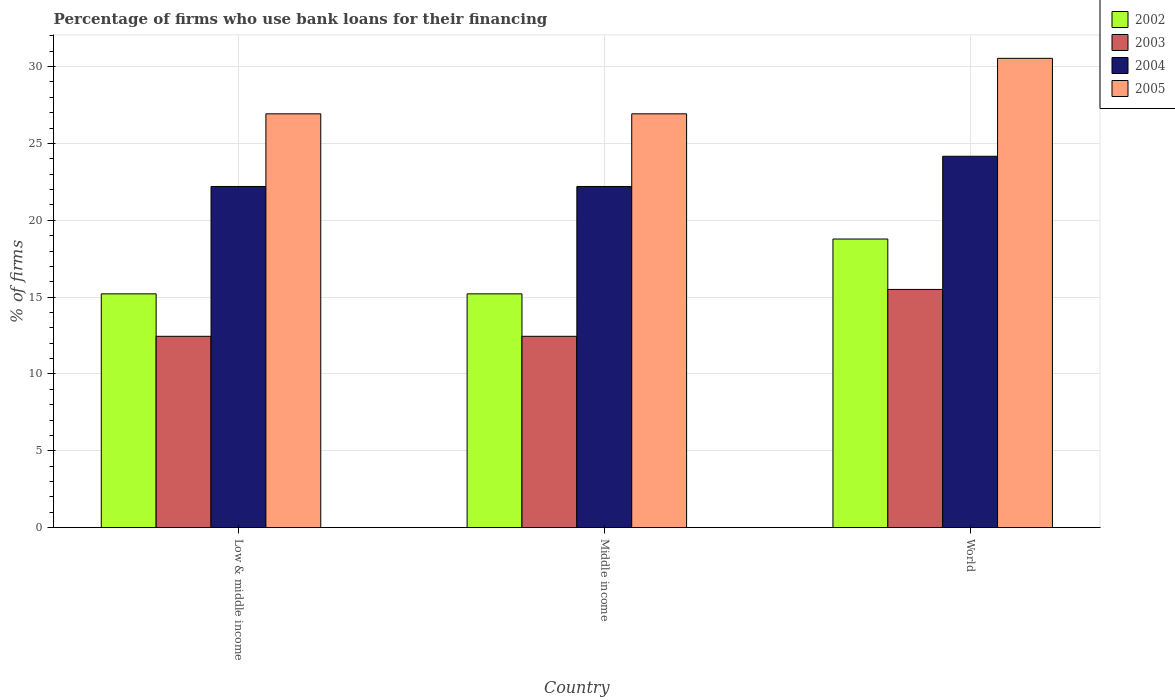How many groups of bars are there?
Keep it short and to the point. 3. What is the label of the 3rd group of bars from the left?
Your response must be concise. World. What is the percentage of firms who use bank loans for their financing in 2005 in Middle income?
Ensure brevity in your answer.  26.93. Across all countries, what is the maximum percentage of firms who use bank loans for their financing in 2003?
Provide a succinct answer. 15.5. Across all countries, what is the minimum percentage of firms who use bank loans for their financing in 2005?
Offer a terse response. 26.93. What is the total percentage of firms who use bank loans for their financing in 2002 in the graph?
Give a very brief answer. 49.21. What is the difference between the percentage of firms who use bank loans for their financing in 2004 in Middle income and the percentage of firms who use bank loans for their financing in 2003 in World?
Your answer should be very brief. 6.7. What is the average percentage of firms who use bank loans for their financing in 2004 per country?
Provide a succinct answer. 22.86. What is the difference between the percentage of firms who use bank loans for their financing of/in 2005 and percentage of firms who use bank loans for their financing of/in 2002 in World?
Provide a succinct answer. 11.76. What is the ratio of the percentage of firms who use bank loans for their financing in 2003 in Middle income to that in World?
Offer a terse response. 0.8. Is the percentage of firms who use bank loans for their financing in 2005 in Middle income less than that in World?
Your answer should be very brief. Yes. Is the difference between the percentage of firms who use bank loans for their financing in 2005 in Low & middle income and World greater than the difference between the percentage of firms who use bank loans for their financing in 2002 in Low & middle income and World?
Your response must be concise. No. What is the difference between the highest and the second highest percentage of firms who use bank loans for their financing in 2003?
Make the answer very short. -3.05. What is the difference between the highest and the lowest percentage of firms who use bank loans for their financing in 2002?
Make the answer very short. 3.57. Is the sum of the percentage of firms who use bank loans for their financing in 2003 in Low & middle income and Middle income greater than the maximum percentage of firms who use bank loans for their financing in 2005 across all countries?
Ensure brevity in your answer.  No. What does the 1st bar from the right in Middle income represents?
Offer a terse response. 2005. Is it the case that in every country, the sum of the percentage of firms who use bank loans for their financing in 2004 and percentage of firms who use bank loans for their financing in 2005 is greater than the percentage of firms who use bank loans for their financing in 2003?
Your response must be concise. Yes. How many bars are there?
Ensure brevity in your answer.  12. Are the values on the major ticks of Y-axis written in scientific E-notation?
Your response must be concise. No. Does the graph contain any zero values?
Ensure brevity in your answer.  No. Does the graph contain grids?
Offer a terse response. Yes. How many legend labels are there?
Ensure brevity in your answer.  4. How are the legend labels stacked?
Give a very brief answer. Vertical. What is the title of the graph?
Your answer should be compact. Percentage of firms who use bank loans for their financing. Does "1990" appear as one of the legend labels in the graph?
Offer a very short reply. No. What is the label or title of the X-axis?
Make the answer very short. Country. What is the label or title of the Y-axis?
Provide a succinct answer. % of firms. What is the % of firms in 2002 in Low & middle income?
Offer a very short reply. 15.21. What is the % of firms of 2003 in Low & middle income?
Keep it short and to the point. 12.45. What is the % of firms in 2005 in Low & middle income?
Give a very brief answer. 26.93. What is the % of firms in 2002 in Middle income?
Offer a very short reply. 15.21. What is the % of firms in 2003 in Middle income?
Keep it short and to the point. 12.45. What is the % of firms of 2005 in Middle income?
Provide a succinct answer. 26.93. What is the % of firms in 2002 in World?
Make the answer very short. 18.78. What is the % of firms in 2003 in World?
Keep it short and to the point. 15.5. What is the % of firms of 2004 in World?
Your answer should be compact. 24.17. What is the % of firms in 2005 in World?
Make the answer very short. 30.54. Across all countries, what is the maximum % of firms of 2002?
Provide a short and direct response. 18.78. Across all countries, what is the maximum % of firms of 2003?
Your answer should be very brief. 15.5. Across all countries, what is the maximum % of firms in 2004?
Your response must be concise. 24.17. Across all countries, what is the maximum % of firms of 2005?
Make the answer very short. 30.54. Across all countries, what is the minimum % of firms of 2002?
Ensure brevity in your answer.  15.21. Across all countries, what is the minimum % of firms of 2003?
Ensure brevity in your answer.  12.45. Across all countries, what is the minimum % of firms of 2005?
Ensure brevity in your answer.  26.93. What is the total % of firms of 2002 in the graph?
Your response must be concise. 49.21. What is the total % of firms of 2003 in the graph?
Your answer should be compact. 40.4. What is the total % of firms of 2004 in the graph?
Your answer should be compact. 68.57. What is the total % of firms of 2005 in the graph?
Give a very brief answer. 84.39. What is the difference between the % of firms in 2003 in Low & middle income and that in Middle income?
Your response must be concise. 0. What is the difference between the % of firms of 2004 in Low & middle income and that in Middle income?
Keep it short and to the point. 0. What is the difference between the % of firms in 2002 in Low & middle income and that in World?
Ensure brevity in your answer.  -3.57. What is the difference between the % of firms of 2003 in Low & middle income and that in World?
Keep it short and to the point. -3.05. What is the difference between the % of firms of 2004 in Low & middle income and that in World?
Ensure brevity in your answer.  -1.97. What is the difference between the % of firms in 2005 in Low & middle income and that in World?
Offer a terse response. -3.61. What is the difference between the % of firms of 2002 in Middle income and that in World?
Offer a terse response. -3.57. What is the difference between the % of firms in 2003 in Middle income and that in World?
Make the answer very short. -3.05. What is the difference between the % of firms of 2004 in Middle income and that in World?
Your answer should be very brief. -1.97. What is the difference between the % of firms in 2005 in Middle income and that in World?
Offer a terse response. -3.61. What is the difference between the % of firms in 2002 in Low & middle income and the % of firms in 2003 in Middle income?
Your answer should be very brief. 2.76. What is the difference between the % of firms in 2002 in Low & middle income and the % of firms in 2004 in Middle income?
Provide a short and direct response. -6.99. What is the difference between the % of firms in 2002 in Low & middle income and the % of firms in 2005 in Middle income?
Your answer should be compact. -11.72. What is the difference between the % of firms of 2003 in Low & middle income and the % of firms of 2004 in Middle income?
Keep it short and to the point. -9.75. What is the difference between the % of firms in 2003 in Low & middle income and the % of firms in 2005 in Middle income?
Ensure brevity in your answer.  -14.48. What is the difference between the % of firms in 2004 in Low & middle income and the % of firms in 2005 in Middle income?
Keep it short and to the point. -4.73. What is the difference between the % of firms in 2002 in Low & middle income and the % of firms in 2003 in World?
Provide a short and direct response. -0.29. What is the difference between the % of firms in 2002 in Low & middle income and the % of firms in 2004 in World?
Make the answer very short. -8.95. What is the difference between the % of firms of 2002 in Low & middle income and the % of firms of 2005 in World?
Make the answer very short. -15.33. What is the difference between the % of firms of 2003 in Low & middle income and the % of firms of 2004 in World?
Your response must be concise. -11.72. What is the difference between the % of firms of 2003 in Low & middle income and the % of firms of 2005 in World?
Keep it short and to the point. -18.09. What is the difference between the % of firms of 2004 in Low & middle income and the % of firms of 2005 in World?
Ensure brevity in your answer.  -8.34. What is the difference between the % of firms in 2002 in Middle income and the % of firms in 2003 in World?
Offer a terse response. -0.29. What is the difference between the % of firms of 2002 in Middle income and the % of firms of 2004 in World?
Ensure brevity in your answer.  -8.95. What is the difference between the % of firms in 2002 in Middle income and the % of firms in 2005 in World?
Offer a very short reply. -15.33. What is the difference between the % of firms of 2003 in Middle income and the % of firms of 2004 in World?
Make the answer very short. -11.72. What is the difference between the % of firms in 2003 in Middle income and the % of firms in 2005 in World?
Give a very brief answer. -18.09. What is the difference between the % of firms in 2004 in Middle income and the % of firms in 2005 in World?
Provide a short and direct response. -8.34. What is the average % of firms of 2002 per country?
Your answer should be very brief. 16.4. What is the average % of firms in 2003 per country?
Keep it short and to the point. 13.47. What is the average % of firms of 2004 per country?
Your response must be concise. 22.86. What is the average % of firms of 2005 per country?
Offer a very short reply. 28.13. What is the difference between the % of firms in 2002 and % of firms in 2003 in Low & middle income?
Offer a very short reply. 2.76. What is the difference between the % of firms in 2002 and % of firms in 2004 in Low & middle income?
Give a very brief answer. -6.99. What is the difference between the % of firms in 2002 and % of firms in 2005 in Low & middle income?
Keep it short and to the point. -11.72. What is the difference between the % of firms in 2003 and % of firms in 2004 in Low & middle income?
Ensure brevity in your answer.  -9.75. What is the difference between the % of firms of 2003 and % of firms of 2005 in Low & middle income?
Provide a succinct answer. -14.48. What is the difference between the % of firms in 2004 and % of firms in 2005 in Low & middle income?
Offer a terse response. -4.73. What is the difference between the % of firms of 2002 and % of firms of 2003 in Middle income?
Offer a very short reply. 2.76. What is the difference between the % of firms in 2002 and % of firms in 2004 in Middle income?
Your answer should be very brief. -6.99. What is the difference between the % of firms of 2002 and % of firms of 2005 in Middle income?
Your response must be concise. -11.72. What is the difference between the % of firms in 2003 and % of firms in 2004 in Middle income?
Make the answer very short. -9.75. What is the difference between the % of firms of 2003 and % of firms of 2005 in Middle income?
Provide a succinct answer. -14.48. What is the difference between the % of firms of 2004 and % of firms of 2005 in Middle income?
Offer a terse response. -4.73. What is the difference between the % of firms in 2002 and % of firms in 2003 in World?
Your response must be concise. 3.28. What is the difference between the % of firms of 2002 and % of firms of 2004 in World?
Ensure brevity in your answer.  -5.39. What is the difference between the % of firms in 2002 and % of firms in 2005 in World?
Keep it short and to the point. -11.76. What is the difference between the % of firms in 2003 and % of firms in 2004 in World?
Give a very brief answer. -8.67. What is the difference between the % of firms in 2003 and % of firms in 2005 in World?
Your response must be concise. -15.04. What is the difference between the % of firms in 2004 and % of firms in 2005 in World?
Give a very brief answer. -6.37. What is the ratio of the % of firms of 2002 in Low & middle income to that in Middle income?
Your answer should be very brief. 1. What is the ratio of the % of firms in 2003 in Low & middle income to that in Middle income?
Give a very brief answer. 1. What is the ratio of the % of firms of 2002 in Low & middle income to that in World?
Offer a terse response. 0.81. What is the ratio of the % of firms of 2003 in Low & middle income to that in World?
Offer a very short reply. 0.8. What is the ratio of the % of firms in 2004 in Low & middle income to that in World?
Your answer should be compact. 0.92. What is the ratio of the % of firms of 2005 in Low & middle income to that in World?
Provide a short and direct response. 0.88. What is the ratio of the % of firms in 2002 in Middle income to that in World?
Ensure brevity in your answer.  0.81. What is the ratio of the % of firms of 2003 in Middle income to that in World?
Ensure brevity in your answer.  0.8. What is the ratio of the % of firms of 2004 in Middle income to that in World?
Provide a short and direct response. 0.92. What is the ratio of the % of firms in 2005 in Middle income to that in World?
Your answer should be compact. 0.88. What is the difference between the highest and the second highest % of firms of 2002?
Offer a very short reply. 3.57. What is the difference between the highest and the second highest % of firms in 2003?
Keep it short and to the point. 3.05. What is the difference between the highest and the second highest % of firms of 2004?
Offer a terse response. 1.97. What is the difference between the highest and the second highest % of firms in 2005?
Give a very brief answer. 3.61. What is the difference between the highest and the lowest % of firms in 2002?
Your answer should be very brief. 3.57. What is the difference between the highest and the lowest % of firms in 2003?
Offer a terse response. 3.05. What is the difference between the highest and the lowest % of firms of 2004?
Offer a terse response. 1.97. What is the difference between the highest and the lowest % of firms in 2005?
Make the answer very short. 3.61. 